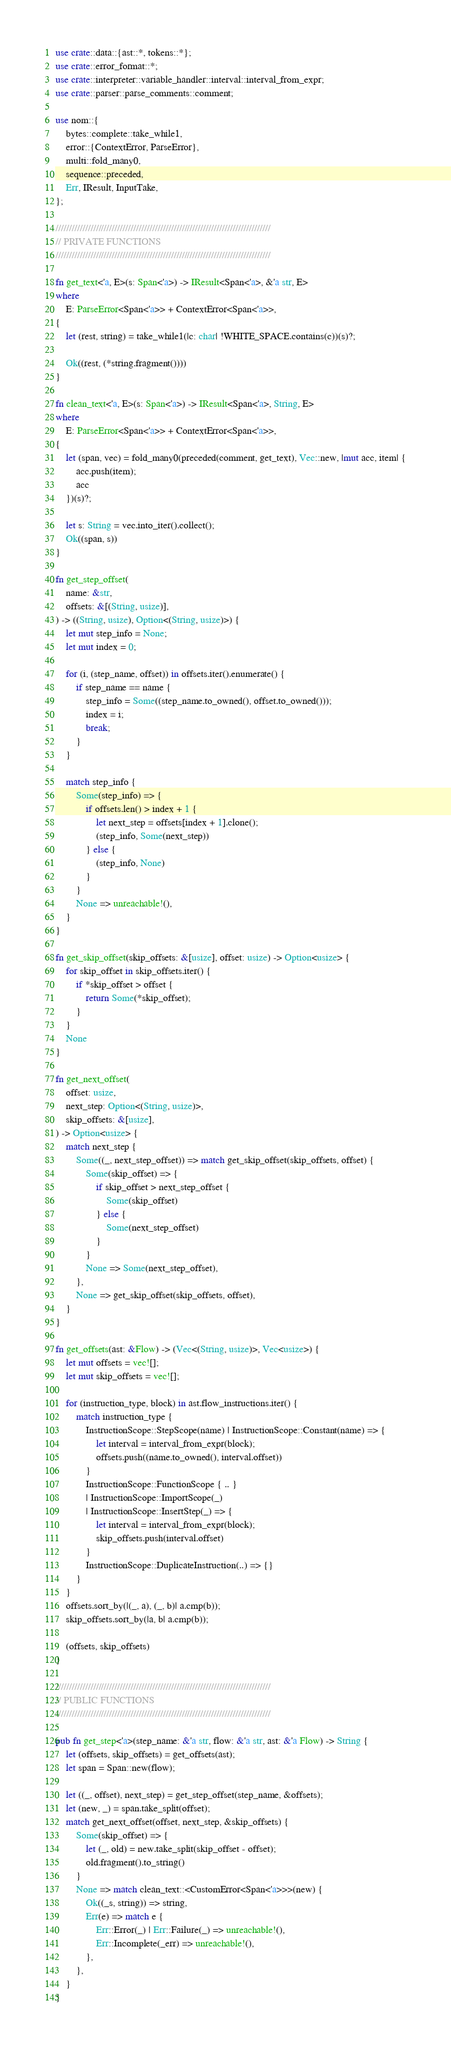<code> <loc_0><loc_0><loc_500><loc_500><_Rust_>use crate::data::{ast::*, tokens::*};
use crate::error_format::*;
use crate::interpreter::variable_handler::interval::interval_from_expr;
use crate::parser::parse_comments::comment;

use nom::{
    bytes::complete::take_while1,
    error::{ContextError, ParseError},
    multi::fold_many0,
    sequence::preceded,
    Err, IResult, InputTake,
};

////////////////////////////////////////////////////////////////////////////////
// PRIVATE FUNCTIONS
////////////////////////////////////////////////////////////////////////////////

fn get_text<'a, E>(s: Span<'a>) -> IResult<Span<'a>, &'a str, E>
where
    E: ParseError<Span<'a>> + ContextError<Span<'a>>,
{
    let (rest, string) = take_while1(|c: char| !WHITE_SPACE.contains(c))(s)?;

    Ok((rest, (*string.fragment())))
}

fn clean_text<'a, E>(s: Span<'a>) -> IResult<Span<'a>, String, E>
where
    E: ParseError<Span<'a>> + ContextError<Span<'a>>,
{
    let (span, vec) = fold_many0(preceded(comment, get_text), Vec::new, |mut acc, item| {
        acc.push(item);
        acc
    })(s)?;

    let s: String = vec.into_iter().collect();
    Ok((span, s))
}

fn get_step_offset(
    name: &str,
    offsets: &[(String, usize)],
) -> ((String, usize), Option<(String, usize)>) {
    let mut step_info = None;
    let mut index = 0;

    for (i, (step_name, offset)) in offsets.iter().enumerate() {
        if step_name == name {
            step_info = Some((step_name.to_owned(), offset.to_owned()));
            index = i;
            break;
        }
    }

    match step_info {
        Some(step_info) => {
            if offsets.len() > index + 1 {
                let next_step = offsets[index + 1].clone();
                (step_info, Some(next_step))
            } else {
                (step_info, None)
            }
        }
        None => unreachable!(),
    }
}

fn get_skip_offset(skip_offsets: &[usize], offset: usize) -> Option<usize> {
    for skip_offset in skip_offsets.iter() {
        if *skip_offset > offset {
            return Some(*skip_offset);
        }
    }
    None
}

fn get_next_offset(
    offset: usize,
    next_step: Option<(String, usize)>,
    skip_offsets: &[usize],
) -> Option<usize> {
    match next_step {
        Some((_, next_step_offset)) => match get_skip_offset(skip_offsets, offset) {
            Some(skip_offset) => {
                if skip_offset > next_step_offset {
                    Some(skip_offset)
                } else {
                    Some(next_step_offset)
                }
            }
            None => Some(next_step_offset),
        },
        None => get_skip_offset(skip_offsets, offset),
    }
}

fn get_offsets(ast: &Flow) -> (Vec<(String, usize)>, Vec<usize>) {
    let mut offsets = vec![];
    let mut skip_offsets = vec![];

    for (instruction_type, block) in ast.flow_instructions.iter() {
        match instruction_type {
            InstructionScope::StepScope(name) | InstructionScope::Constant(name) => {
                let interval = interval_from_expr(block);
                offsets.push((name.to_owned(), interval.offset))
            }
            InstructionScope::FunctionScope { .. }
            | InstructionScope::ImportScope(_)
            | InstructionScope::InsertStep(_) => {
                let interval = interval_from_expr(block);
                skip_offsets.push(interval.offset)
            }
            InstructionScope::DuplicateInstruction(..) => {}
        }
    }
    offsets.sort_by(|(_, a), (_, b)| a.cmp(b));
    skip_offsets.sort_by(|a, b| a.cmp(b));

    (offsets, skip_offsets)
}

////////////////////////////////////////////////////////////////////////////////
// PUBLIC FUNCTIONS
////////////////////////////////////////////////////////////////////////////////

pub fn get_step<'a>(step_name: &'a str, flow: &'a str, ast: &'a Flow) -> String {
    let (offsets, skip_offsets) = get_offsets(ast);
    let span = Span::new(flow);

    let ((_, offset), next_step) = get_step_offset(step_name, &offsets);
    let (new, _) = span.take_split(offset);
    match get_next_offset(offset, next_step, &skip_offsets) {
        Some(skip_offset) => {
            let (_, old) = new.take_split(skip_offset - offset);
            old.fragment().to_string()
        }
        None => match clean_text::<CustomError<Span<'a>>>(new) {
            Ok((_s, string)) => string,
            Err(e) => match e {
                Err::Error(_) | Err::Failure(_) => unreachable!(),
                Err::Incomplete(_err) => unreachable!(),
            },
        },
    }
}
</code> 